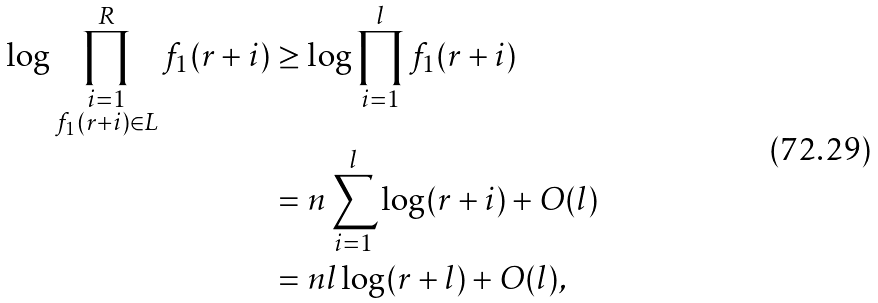Convert formula to latex. <formula><loc_0><loc_0><loc_500><loc_500>\log \prod _ { \substack { i = 1 \\ f _ { 1 } ( r + i ) \in L } } ^ { R } f _ { 1 } ( r + i ) & \geq \log \prod _ { i = 1 } ^ { l } f _ { 1 } ( r + i ) \\ & = n \sum _ { i = 1 } ^ { l } \log ( r + i ) + O ( l ) \\ & = n l \log ( r + l ) + O ( l ) ,</formula> 